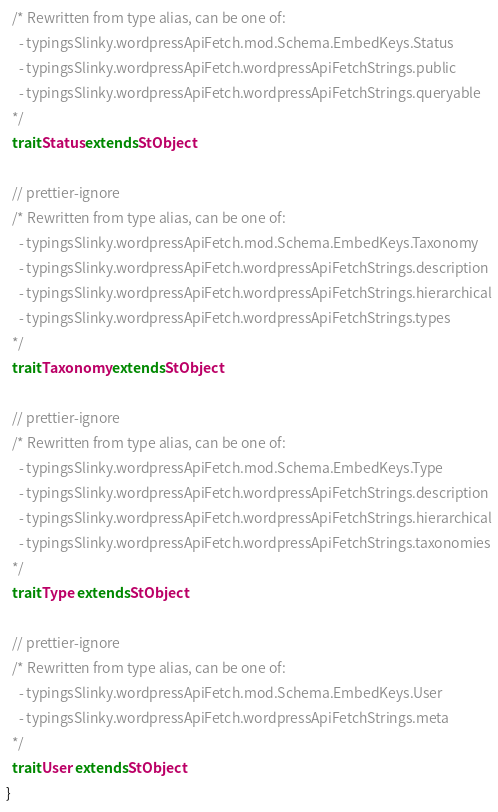<code> <loc_0><loc_0><loc_500><loc_500><_Scala_>  /* Rewritten from type alias, can be one of: 
    - typingsSlinky.wordpressApiFetch.mod.Schema.EmbedKeys.Status
    - typingsSlinky.wordpressApiFetch.wordpressApiFetchStrings.public
    - typingsSlinky.wordpressApiFetch.wordpressApiFetchStrings.queryable
  */
  trait Status extends StObject
  
  // prettier-ignore
  /* Rewritten from type alias, can be one of: 
    - typingsSlinky.wordpressApiFetch.mod.Schema.EmbedKeys.Taxonomy
    - typingsSlinky.wordpressApiFetch.wordpressApiFetchStrings.description
    - typingsSlinky.wordpressApiFetch.wordpressApiFetchStrings.hierarchical
    - typingsSlinky.wordpressApiFetch.wordpressApiFetchStrings.types
  */
  trait Taxonomy extends StObject
  
  // prettier-ignore
  /* Rewritten from type alias, can be one of: 
    - typingsSlinky.wordpressApiFetch.mod.Schema.EmbedKeys.Type
    - typingsSlinky.wordpressApiFetch.wordpressApiFetchStrings.description
    - typingsSlinky.wordpressApiFetch.wordpressApiFetchStrings.hierarchical
    - typingsSlinky.wordpressApiFetch.wordpressApiFetchStrings.taxonomies
  */
  trait Type extends StObject
  
  // prettier-ignore
  /* Rewritten from type alias, can be one of: 
    - typingsSlinky.wordpressApiFetch.mod.Schema.EmbedKeys.User
    - typingsSlinky.wordpressApiFetch.wordpressApiFetchStrings.meta
  */
  trait User extends StObject
}
</code> 